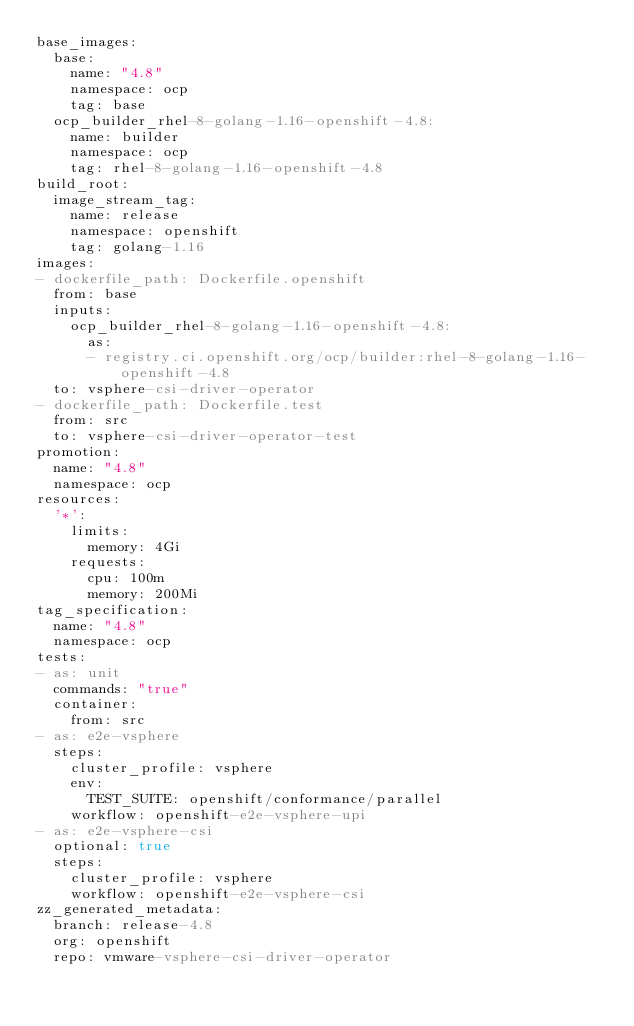Convert code to text. <code><loc_0><loc_0><loc_500><loc_500><_YAML_>base_images:
  base:
    name: "4.8"
    namespace: ocp
    tag: base
  ocp_builder_rhel-8-golang-1.16-openshift-4.8:
    name: builder
    namespace: ocp
    tag: rhel-8-golang-1.16-openshift-4.8
build_root:
  image_stream_tag:
    name: release
    namespace: openshift
    tag: golang-1.16
images:
- dockerfile_path: Dockerfile.openshift
  from: base
  inputs:
    ocp_builder_rhel-8-golang-1.16-openshift-4.8:
      as:
      - registry.ci.openshift.org/ocp/builder:rhel-8-golang-1.16-openshift-4.8
  to: vsphere-csi-driver-operator
- dockerfile_path: Dockerfile.test
  from: src
  to: vsphere-csi-driver-operator-test
promotion:
  name: "4.8"
  namespace: ocp
resources:
  '*':
    limits:
      memory: 4Gi
    requests:
      cpu: 100m
      memory: 200Mi
tag_specification:
  name: "4.8"
  namespace: ocp
tests:
- as: unit
  commands: "true"
  container:
    from: src
- as: e2e-vsphere
  steps:
    cluster_profile: vsphere
    env:
      TEST_SUITE: openshift/conformance/parallel
    workflow: openshift-e2e-vsphere-upi
- as: e2e-vsphere-csi
  optional: true
  steps:
    cluster_profile: vsphere
    workflow: openshift-e2e-vsphere-csi
zz_generated_metadata:
  branch: release-4.8
  org: openshift
  repo: vmware-vsphere-csi-driver-operator
</code> 